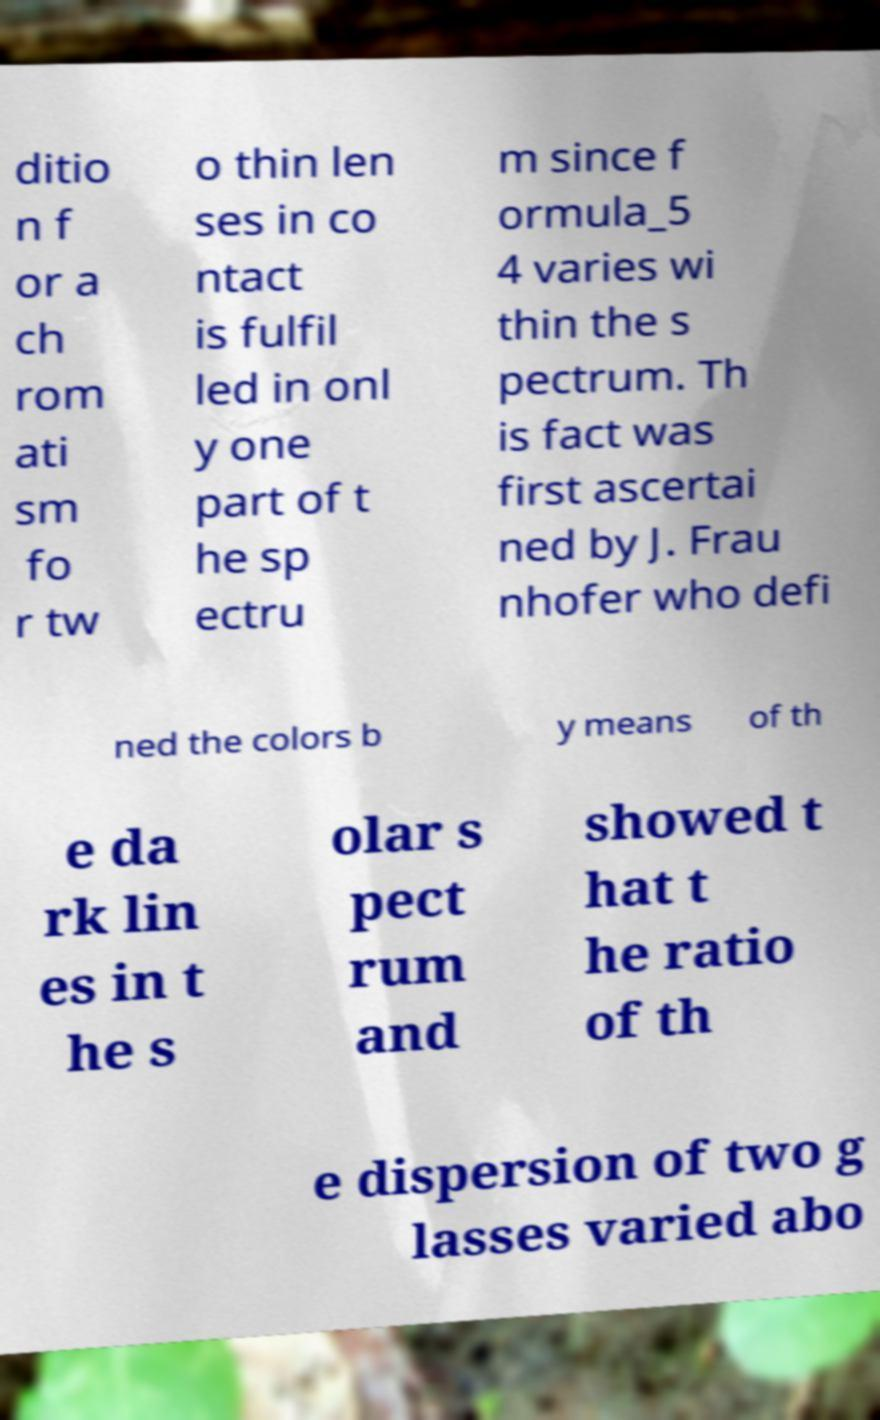There's text embedded in this image that I need extracted. Can you transcribe it verbatim? ditio n f or a ch rom ati sm fo r tw o thin len ses in co ntact is fulfil led in onl y one part of t he sp ectru m since f ormula_5 4 varies wi thin the s pectrum. Th is fact was first ascertai ned by J. Frau nhofer who defi ned the colors b y means of th e da rk lin es in t he s olar s pect rum and showed t hat t he ratio of th e dispersion of two g lasses varied abo 